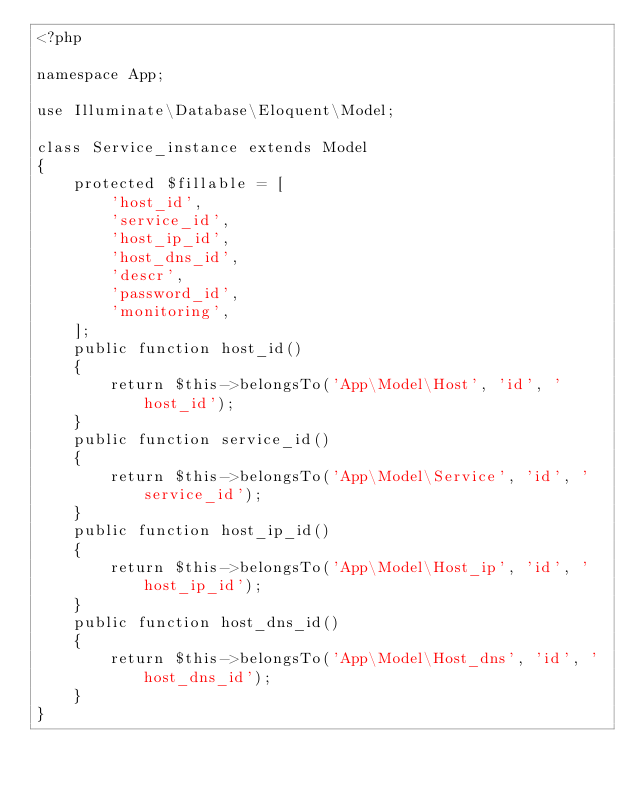Convert code to text. <code><loc_0><loc_0><loc_500><loc_500><_PHP_><?php

namespace App;

use Illuminate\Database\Eloquent\Model;

class Service_instance extends Model
{
    protected $fillable = [
        'host_id',
        'service_id',
        'host_ip_id',
        'host_dns_id',
        'descr',
        'password_id',
        'monitoring',
    ];
    public function host_id()
    {
        return $this->belongsTo('App\Model\Host', 'id', 'host_id');
    }
    public function service_id()
    {
        return $this->belongsTo('App\Model\Service', 'id', 'service_id');
    }
    public function host_ip_id()
    {
        return $this->belongsTo('App\Model\Host_ip', 'id', 'host_ip_id');
    }
    public function host_dns_id()
    {
        return $this->belongsTo('App\Model\Host_dns', 'id', 'host_dns_id');
    }
}
</code> 